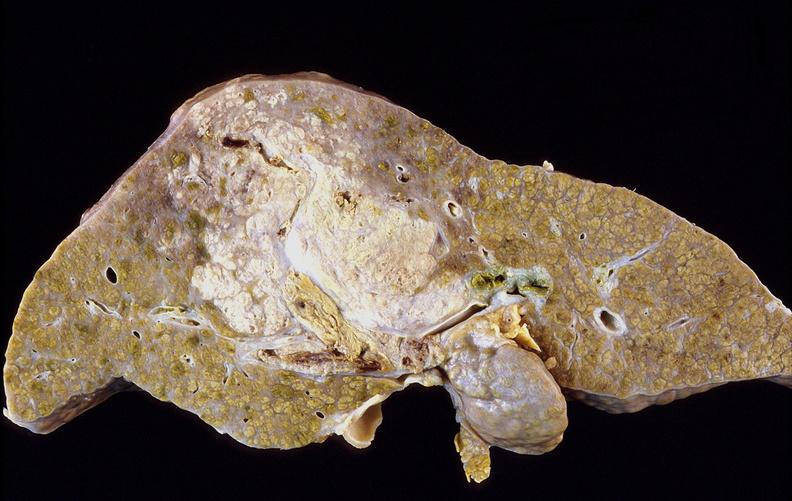does pierre robin sndrome show hepatocellular carcinoma, hepatitis c positive?
Answer the question using a single word or phrase. No 